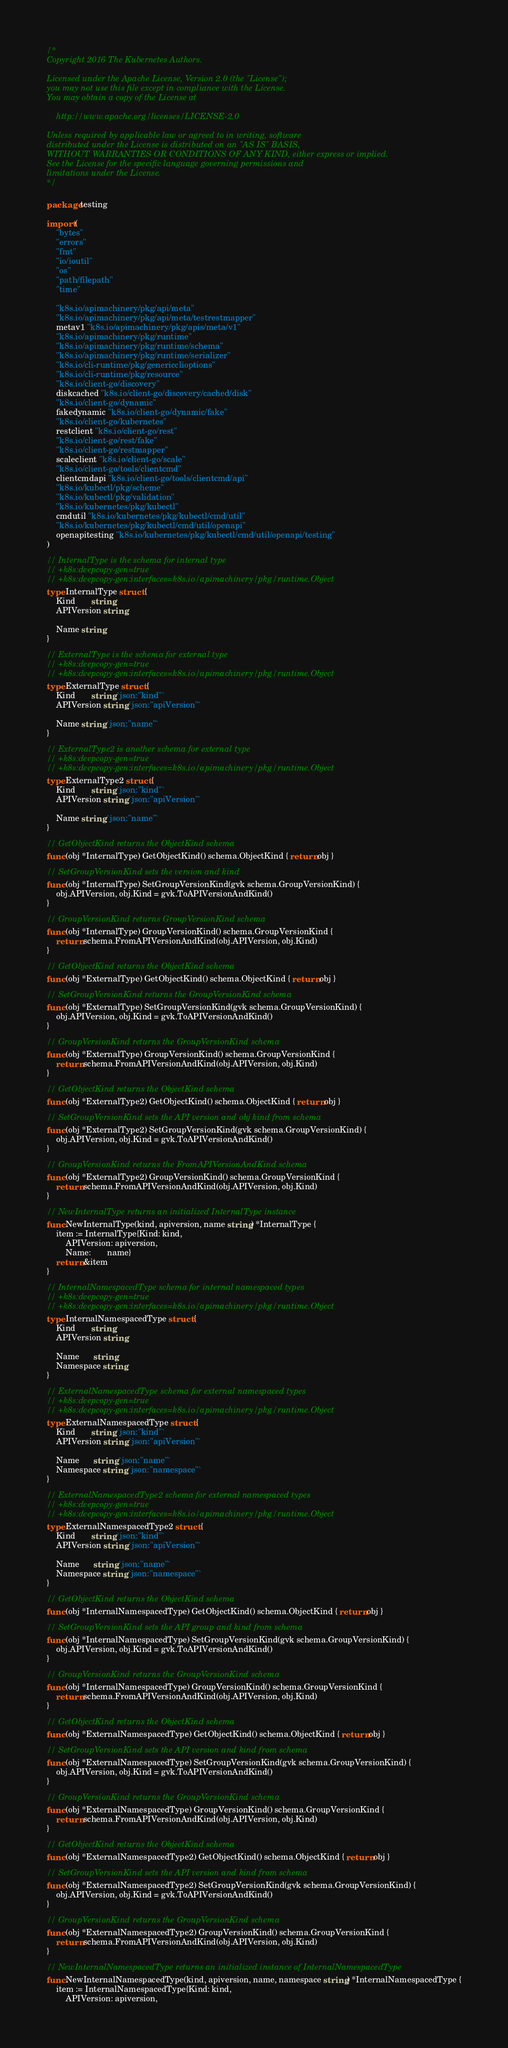Convert code to text. <code><loc_0><loc_0><loc_500><loc_500><_Go_>/*
Copyright 2016 The Kubernetes Authors.

Licensed under the Apache License, Version 2.0 (the "License");
you may not use this file except in compliance with the License.
You may obtain a copy of the License at

    http://www.apache.org/licenses/LICENSE-2.0

Unless required by applicable law or agreed to in writing, software
distributed under the License is distributed on an "AS IS" BASIS,
WITHOUT WARRANTIES OR CONDITIONS OF ANY KIND, either express or implied.
See the License for the specific language governing permissions and
limitations under the License.
*/

package testing

import (
	"bytes"
	"errors"
	"fmt"
	"io/ioutil"
	"os"
	"path/filepath"
	"time"

	"k8s.io/apimachinery/pkg/api/meta"
	"k8s.io/apimachinery/pkg/api/meta/testrestmapper"
	metav1 "k8s.io/apimachinery/pkg/apis/meta/v1"
	"k8s.io/apimachinery/pkg/runtime"
	"k8s.io/apimachinery/pkg/runtime/schema"
	"k8s.io/apimachinery/pkg/runtime/serializer"
	"k8s.io/cli-runtime/pkg/genericclioptions"
	"k8s.io/cli-runtime/pkg/resource"
	"k8s.io/client-go/discovery"
	diskcached "k8s.io/client-go/discovery/cached/disk"
	"k8s.io/client-go/dynamic"
	fakedynamic "k8s.io/client-go/dynamic/fake"
	"k8s.io/client-go/kubernetes"
	restclient "k8s.io/client-go/rest"
	"k8s.io/client-go/rest/fake"
	"k8s.io/client-go/restmapper"
	scaleclient "k8s.io/client-go/scale"
	"k8s.io/client-go/tools/clientcmd"
	clientcmdapi "k8s.io/client-go/tools/clientcmd/api"
	"k8s.io/kubectl/pkg/scheme"
	"k8s.io/kubectl/pkg/validation"
	"k8s.io/kubernetes/pkg/kubectl"
	cmdutil "k8s.io/kubernetes/pkg/kubectl/cmd/util"
	"k8s.io/kubernetes/pkg/kubectl/cmd/util/openapi"
	openapitesting "k8s.io/kubernetes/pkg/kubectl/cmd/util/openapi/testing"
)

// InternalType is the schema for internal type
// +k8s:deepcopy-gen=true
// +k8s:deepcopy-gen:interfaces=k8s.io/apimachinery/pkg/runtime.Object
type InternalType struct {
	Kind       string
	APIVersion string

	Name string
}

// ExternalType is the schema for external type
// +k8s:deepcopy-gen=true
// +k8s:deepcopy-gen:interfaces=k8s.io/apimachinery/pkg/runtime.Object
type ExternalType struct {
	Kind       string `json:"kind"`
	APIVersion string `json:"apiVersion"`

	Name string `json:"name"`
}

// ExternalType2 is another schema for external type
// +k8s:deepcopy-gen=true
// +k8s:deepcopy-gen:interfaces=k8s.io/apimachinery/pkg/runtime.Object
type ExternalType2 struct {
	Kind       string `json:"kind"`
	APIVersion string `json:"apiVersion"`

	Name string `json:"name"`
}

// GetObjectKind returns the ObjectKind schema
func (obj *InternalType) GetObjectKind() schema.ObjectKind { return obj }

// SetGroupVersionKind sets the version and kind
func (obj *InternalType) SetGroupVersionKind(gvk schema.GroupVersionKind) {
	obj.APIVersion, obj.Kind = gvk.ToAPIVersionAndKind()
}

// GroupVersionKind returns GroupVersionKind schema
func (obj *InternalType) GroupVersionKind() schema.GroupVersionKind {
	return schema.FromAPIVersionAndKind(obj.APIVersion, obj.Kind)
}

// GetObjectKind returns the ObjectKind schema
func (obj *ExternalType) GetObjectKind() schema.ObjectKind { return obj }

// SetGroupVersionKind returns the GroupVersionKind schema
func (obj *ExternalType) SetGroupVersionKind(gvk schema.GroupVersionKind) {
	obj.APIVersion, obj.Kind = gvk.ToAPIVersionAndKind()
}

// GroupVersionKind returns the GroupVersionKind schema
func (obj *ExternalType) GroupVersionKind() schema.GroupVersionKind {
	return schema.FromAPIVersionAndKind(obj.APIVersion, obj.Kind)
}

// GetObjectKind returns the ObjectKind schema
func (obj *ExternalType2) GetObjectKind() schema.ObjectKind { return obj }

// SetGroupVersionKind sets the API version and obj kind from schema
func (obj *ExternalType2) SetGroupVersionKind(gvk schema.GroupVersionKind) {
	obj.APIVersion, obj.Kind = gvk.ToAPIVersionAndKind()
}

// GroupVersionKind returns the FromAPIVersionAndKind schema
func (obj *ExternalType2) GroupVersionKind() schema.GroupVersionKind {
	return schema.FromAPIVersionAndKind(obj.APIVersion, obj.Kind)
}

// NewInternalType returns an initialized InternalType instance
func NewInternalType(kind, apiversion, name string) *InternalType {
	item := InternalType{Kind: kind,
		APIVersion: apiversion,
		Name:       name}
	return &item
}

// InternalNamespacedType schema for internal namespaced types
// +k8s:deepcopy-gen=true
// +k8s:deepcopy-gen:interfaces=k8s.io/apimachinery/pkg/runtime.Object
type InternalNamespacedType struct {
	Kind       string
	APIVersion string

	Name      string
	Namespace string
}

// ExternalNamespacedType schema for external namespaced types
// +k8s:deepcopy-gen=true
// +k8s:deepcopy-gen:interfaces=k8s.io/apimachinery/pkg/runtime.Object
type ExternalNamespacedType struct {
	Kind       string `json:"kind"`
	APIVersion string `json:"apiVersion"`

	Name      string `json:"name"`
	Namespace string `json:"namespace"`
}

// ExternalNamespacedType2 schema for external namespaced types
// +k8s:deepcopy-gen=true
// +k8s:deepcopy-gen:interfaces=k8s.io/apimachinery/pkg/runtime.Object
type ExternalNamespacedType2 struct {
	Kind       string `json:"kind"`
	APIVersion string `json:"apiVersion"`

	Name      string `json:"name"`
	Namespace string `json:"namespace"`
}

// GetObjectKind returns the ObjectKind schema
func (obj *InternalNamespacedType) GetObjectKind() schema.ObjectKind { return obj }

// SetGroupVersionKind sets the API group and kind from schema
func (obj *InternalNamespacedType) SetGroupVersionKind(gvk schema.GroupVersionKind) {
	obj.APIVersion, obj.Kind = gvk.ToAPIVersionAndKind()
}

// GroupVersionKind returns the GroupVersionKind schema
func (obj *InternalNamespacedType) GroupVersionKind() schema.GroupVersionKind {
	return schema.FromAPIVersionAndKind(obj.APIVersion, obj.Kind)
}

// GetObjectKind returns the ObjectKind schema
func (obj *ExternalNamespacedType) GetObjectKind() schema.ObjectKind { return obj }

// SetGroupVersionKind sets the API version and kind from schema
func (obj *ExternalNamespacedType) SetGroupVersionKind(gvk schema.GroupVersionKind) {
	obj.APIVersion, obj.Kind = gvk.ToAPIVersionAndKind()
}

// GroupVersionKind returns the GroupVersionKind schema
func (obj *ExternalNamespacedType) GroupVersionKind() schema.GroupVersionKind {
	return schema.FromAPIVersionAndKind(obj.APIVersion, obj.Kind)
}

// GetObjectKind returns the ObjectKind schema
func (obj *ExternalNamespacedType2) GetObjectKind() schema.ObjectKind { return obj }

// SetGroupVersionKind sets the API version and kind from schema
func (obj *ExternalNamespacedType2) SetGroupVersionKind(gvk schema.GroupVersionKind) {
	obj.APIVersion, obj.Kind = gvk.ToAPIVersionAndKind()
}

// GroupVersionKind returns the GroupVersionKind schema
func (obj *ExternalNamespacedType2) GroupVersionKind() schema.GroupVersionKind {
	return schema.FromAPIVersionAndKind(obj.APIVersion, obj.Kind)
}

// NewInternalNamespacedType returns an initialized instance of InternalNamespacedType
func NewInternalNamespacedType(kind, apiversion, name, namespace string) *InternalNamespacedType {
	item := InternalNamespacedType{Kind: kind,
		APIVersion: apiversion,</code> 